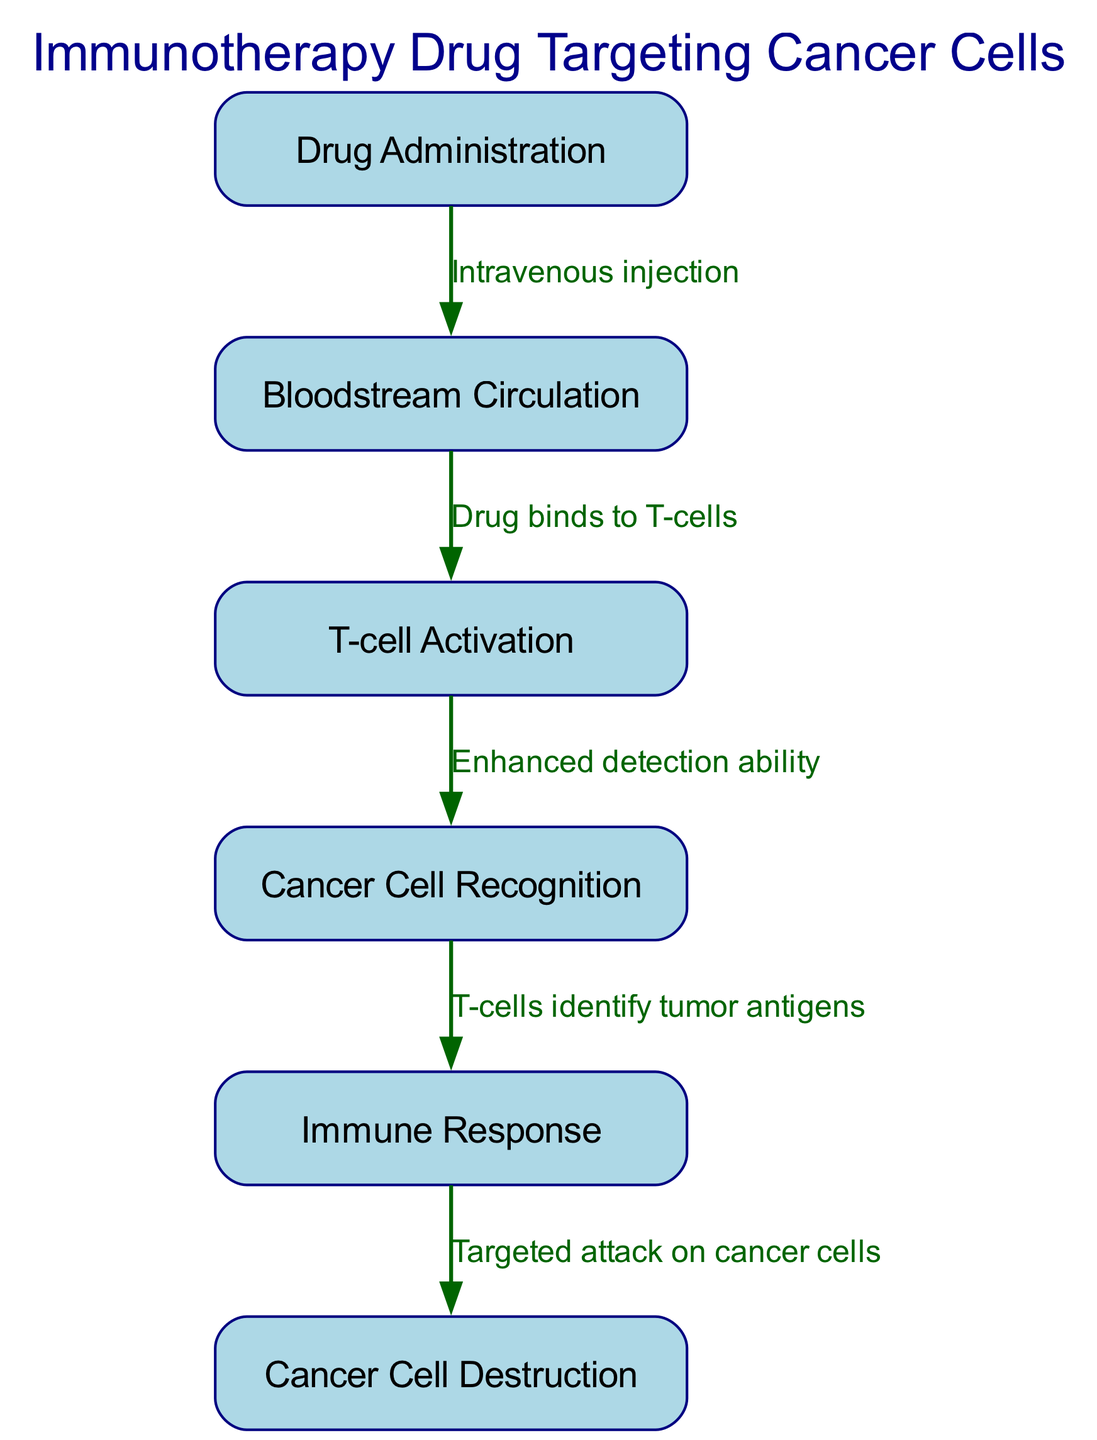What is the first step in the process? The diagram indicates that the first step is "Drug Administration," which is the initial action taken before any other processes occur.
Answer: Drug Administration How many nodes are present in the diagram? By counting the unique nodes listed in the data, there are a total of six nodes representing different steps in the immunotherapy process.
Answer: 6 What type of drug administration is mentioned? The edge connecting the first node to the second node describes the method of administration as "Intravenous injection," which specifies how the drug is given to the patient.
Answer: Intravenous injection What happens after T-cell activation? Following the T-cell activation as indicated in the diagram, the next step is "Cancer Cell Recognition," showing that activated T-cells proceed to identify cancer cells.
Answer: Cancer Cell Recognition What do T-cells identify? According to the diagram, T-cells are said to identify "tumor antigens," which refers to specific markers on cancer cells that the immune system recognizes.
Answer: Tumor antigens How does the drug affect T-cells? The diagram states that the drug "binds to T-cells," indicating that this interaction is key to the immunotherapy process, enabling T-cells to perform their function effectively.
Answer: Binds to T-cells What is the result of the immune response? The immune response is described in the diagram as leading to "Targeted attack on cancer cells," highlighting the ultimate goal of the immunotherapy process.
Answer: Targeted attack on cancer cells What links Bloodstream Circulation to T-cell Activation? The arrow connecting these two nodes is labeled "Drug binds to T-cells," effectively showing that the action of the drug is the key link between bloodstream circulation and T-cell activation.
Answer: Drug binds to T-cells What is the final outcome of the process depicted in the diagram? The final node in the process is "Cancer Cell Destruction," indicating that the ultimate result of the entire sequence is the elimination of cancer cells.
Answer: Cancer Cell Destruction 